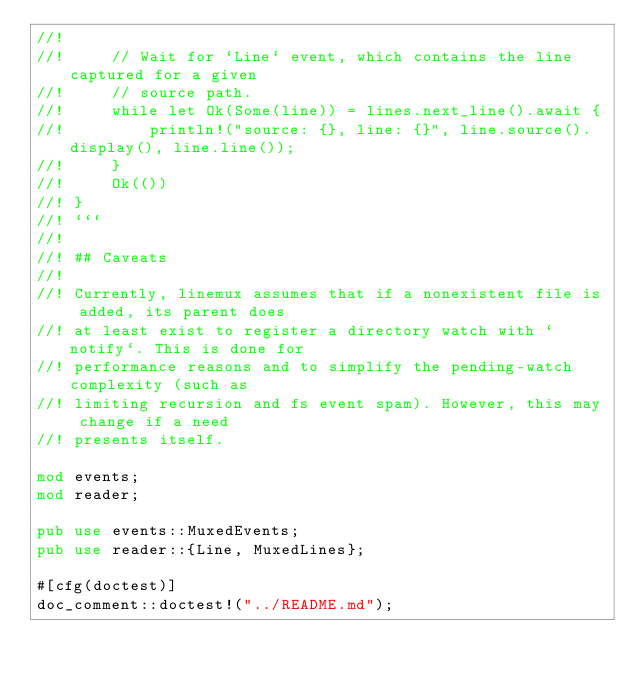<code> <loc_0><loc_0><loc_500><loc_500><_Rust_>//!
//!     // Wait for `Line` event, which contains the line captured for a given
//!     // source path.
//!     while let Ok(Some(line)) = lines.next_line().await {
//!         println!("source: {}, line: {}", line.source().display(), line.line());
//!     }
//!     Ok(())
//! }
//! ```
//!
//! ## Caveats
//!
//! Currently, linemux assumes that if a nonexistent file is added, its parent does
//! at least exist to register a directory watch with `notify`. This is done for
//! performance reasons and to simplify the pending-watch complexity (such as
//! limiting recursion and fs event spam). However, this may change if a need
//! presents itself.

mod events;
mod reader;

pub use events::MuxedEvents;
pub use reader::{Line, MuxedLines};

#[cfg(doctest)]
doc_comment::doctest!("../README.md");
</code> 